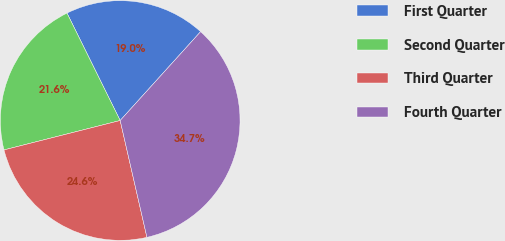Convert chart to OTSL. <chart><loc_0><loc_0><loc_500><loc_500><pie_chart><fcel>First Quarter<fcel>Second Quarter<fcel>Third Quarter<fcel>Fourth Quarter<nl><fcel>19.03%<fcel>21.63%<fcel>24.64%<fcel>34.71%<nl></chart> 